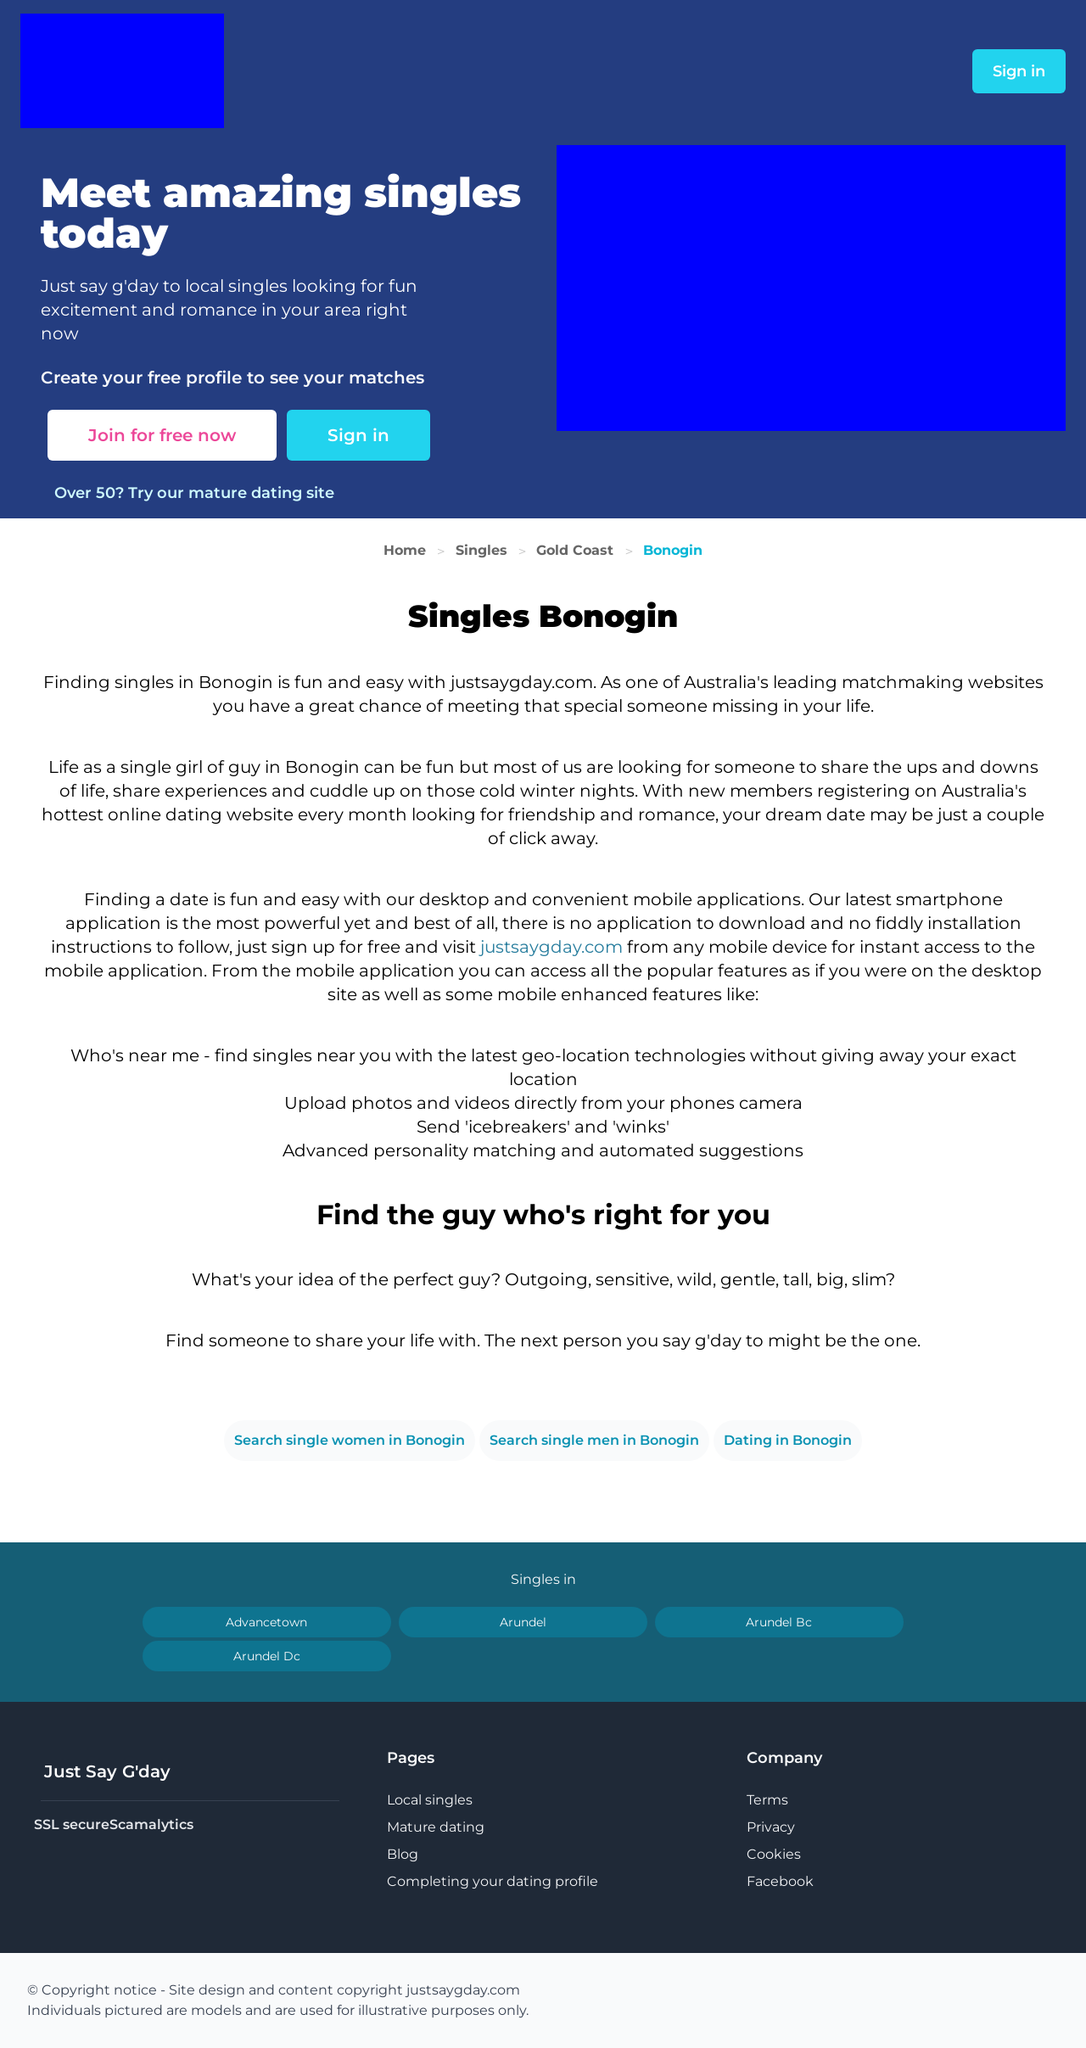Could you guide me through the process of developing this website with HTML? To develop a website similar to the one shown in the image, you would start by structuring your HTML to include elements for navigation, a sign-in button, sections for content about singles in Bonogin, and links for mature dating. You would use CSS for styling to ensure the website is visually appealing, matching the blue and white color scheme shown. Finally, integrating responsive design would ensure the site looks good on both desktops and mobile devices. 